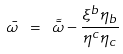Convert formula to latex. <formula><loc_0><loc_0><loc_500><loc_500>\bar { \omega } \ = \ \tilde { \bar { \omega } } - \frac { \xi ^ { b } \eta _ { b } } { \eta ^ { c } \eta _ { c } }</formula> 